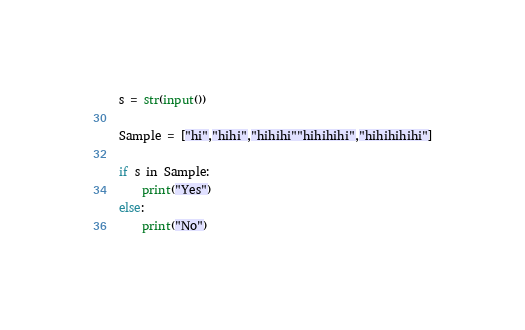<code> <loc_0><loc_0><loc_500><loc_500><_Python_>s = str(input())

Sample = ["hi","hihi","hihihi""hihihihi","hihihihihi"]

if s in Sample:
    print("Yes")
else:
    print("No")
</code> 